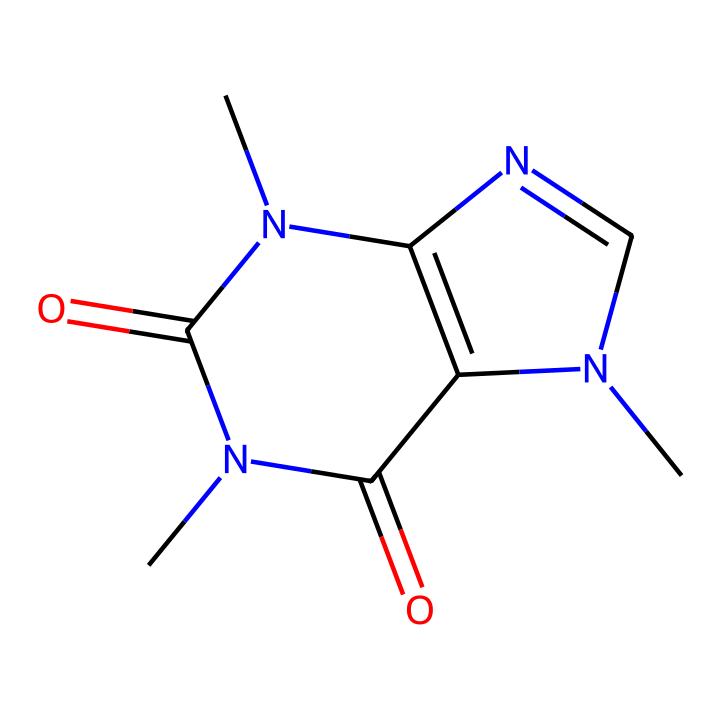What is the molecular formula of caffeine? By analyzing the SMILES representation, we count each type of atom encoded in it. The atoms present are carbon (C), nitrogen (N), and oxygen (O). Specifically, there are 8 carbon atoms, 10 hydrogen atoms, 4 nitrogen atoms, and 2 oxygen atoms. Therefore, the molecular formula can be derived as C8H10N4O2.
Answer: C8H10N4O2 How many ring structures are present in caffeine? In the provided SMILES structure, the parentheses indicate branches and numbers indicate ring closures. Caffeine has two ring structures: one pyrimidine ring and one imidazole ring. Both contribute to the overall cyclic structure of caffeine.
Answer: 2 Does caffeine contain any nitrogen atoms? Looking at the SMILES representation, we can identify at least four instances of nitrogen (N) within the structure, confirming the presence of nitrogen atoms in caffeine.
Answer: yes What functional groups can be identified in caffeine? The chemical structure shows that caffeine contains both carbonyl (C=O) and amine (NH) functional groups. The carbonyls are found at positions within the rings, while the amine groups are attached to the nitrogen atoms. This contributes to its classification as an alkaloid.
Answer: carbonyl and amine What type of organic compound is caffeine? Caffeine is classified as an alkaloid due to the presence of nitrogen atoms and its physiological effects. Alkaloids are a group of naturally occurring organic compounds that mostly contain basic nitrogen atoms and are known for their pharmacological properties.
Answer: alkaloid How many hydrogen bonds can potentially be formed by caffeine in an aqueous environment? Analyzing the location of polar functional groups, such as the nitrogen and oxygen atoms, caffeine may form multiple hydrogen bonds with water molecules. Each nitrogen and oxygen can form hydrogen bonds, resulting in a total of about five potential hydrogen bonds.
Answer: 5 